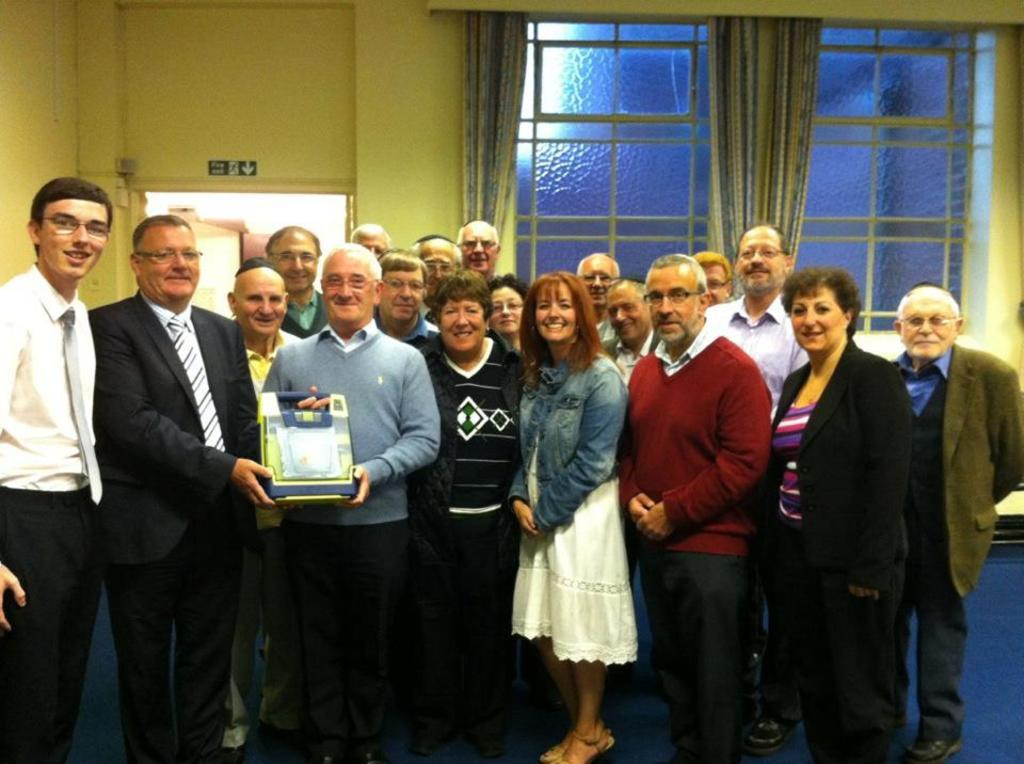What are the people in the image doing? The persons standing on the floor in the image are holding an object in their hands. What can be seen in the background of the image? There are windows, curtains, walls, and a sign board in the background of the image. What type of clam is being sold at the shop in the image? There is no shop present in the image, and therefore no clams are being sold. 